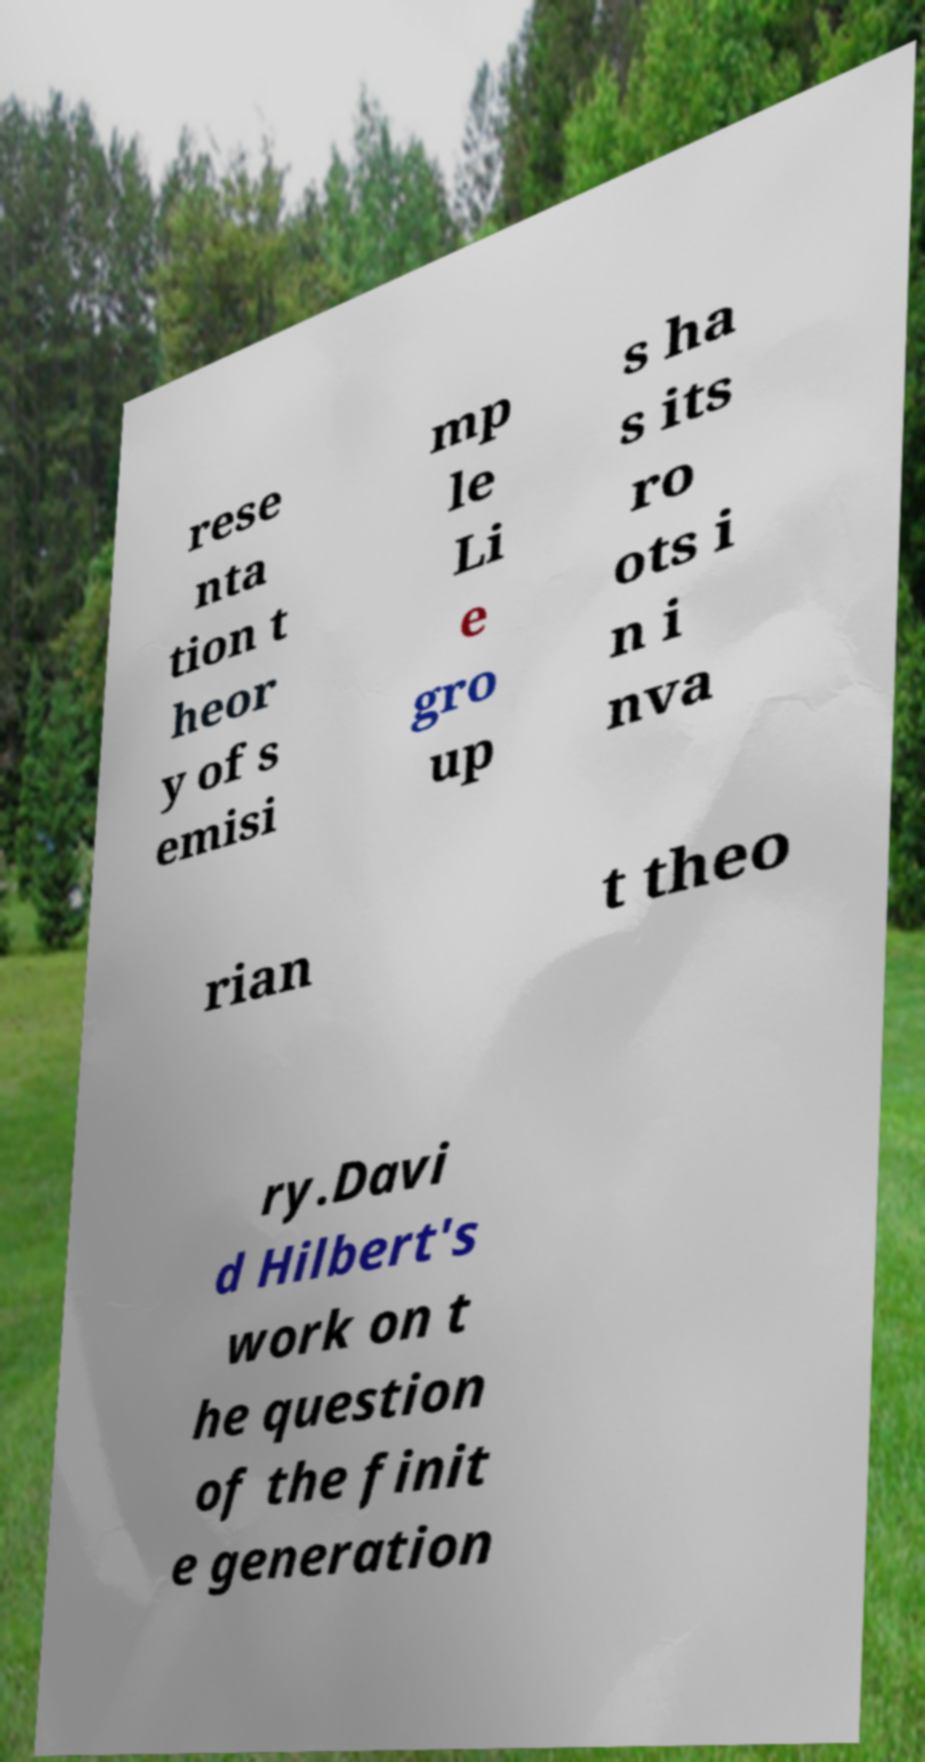Can you read and provide the text displayed in the image?This photo seems to have some interesting text. Can you extract and type it out for me? rese nta tion t heor y of s emisi mp le Li e gro up s ha s its ro ots i n i nva rian t theo ry.Davi d Hilbert's work on t he question of the finit e generation 